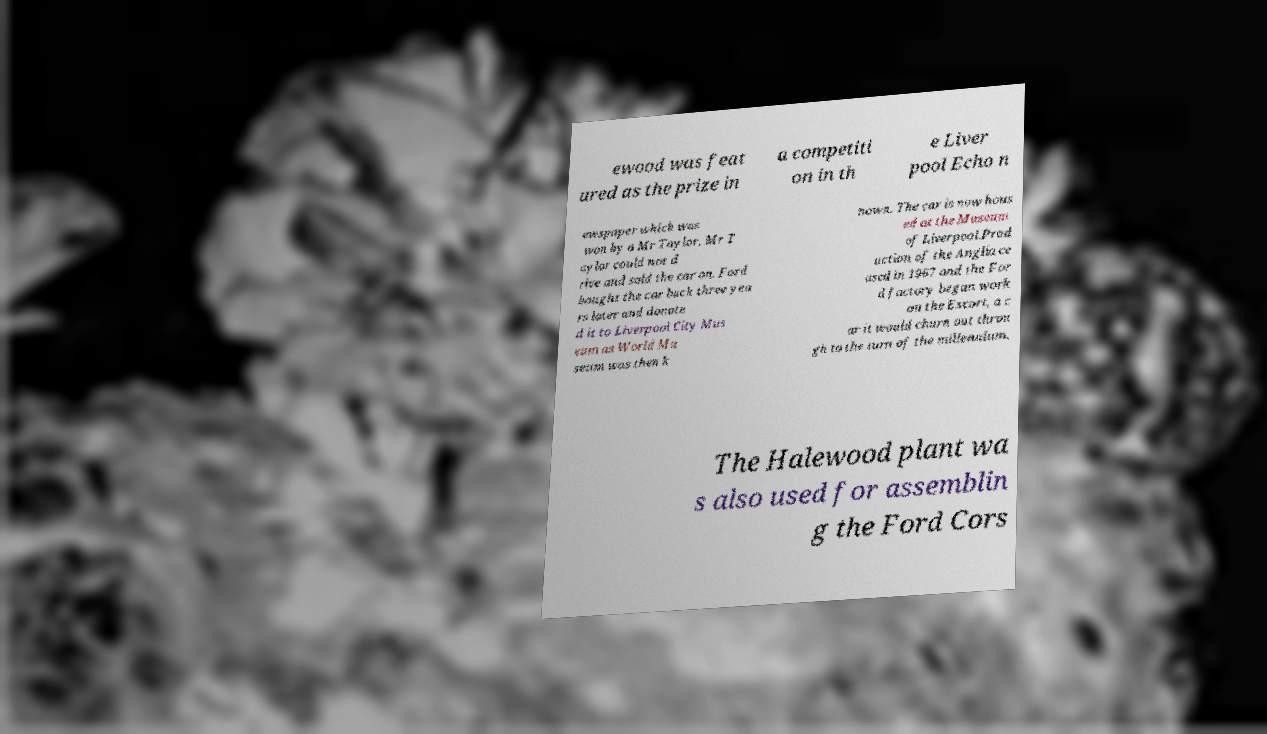I need the written content from this picture converted into text. Can you do that? ewood was feat ured as the prize in a competiti on in th e Liver pool Echo n ewspaper which was won by a Mr Taylor. Mr T aylor could not d rive and sold the car on. Ford bought the car back three yea rs later and donate d it to Liverpool City Mus eum as World Mu seum was then k nown. The car is now hous ed at the Museum of Liverpool.Prod uction of the Anglia ce ased in 1967 and the For d factory began work on the Escort, a c ar it would churn out throu gh to the turn of the millennium. The Halewood plant wa s also used for assemblin g the Ford Cors 